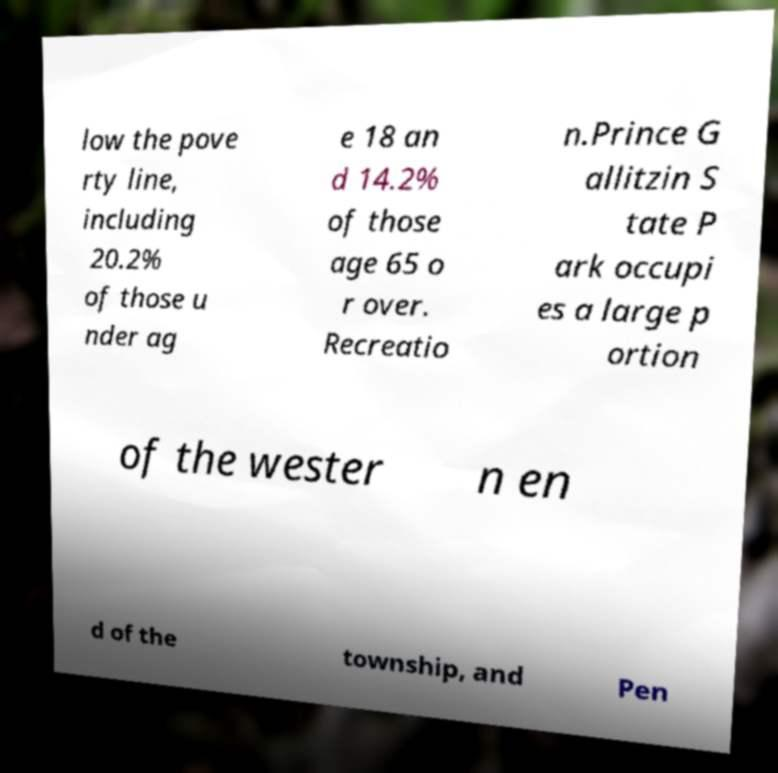Please read and relay the text visible in this image. What does it say? low the pove rty line, including 20.2% of those u nder ag e 18 an d 14.2% of those age 65 o r over. Recreatio n.Prince G allitzin S tate P ark occupi es a large p ortion of the wester n en d of the township, and Pen 